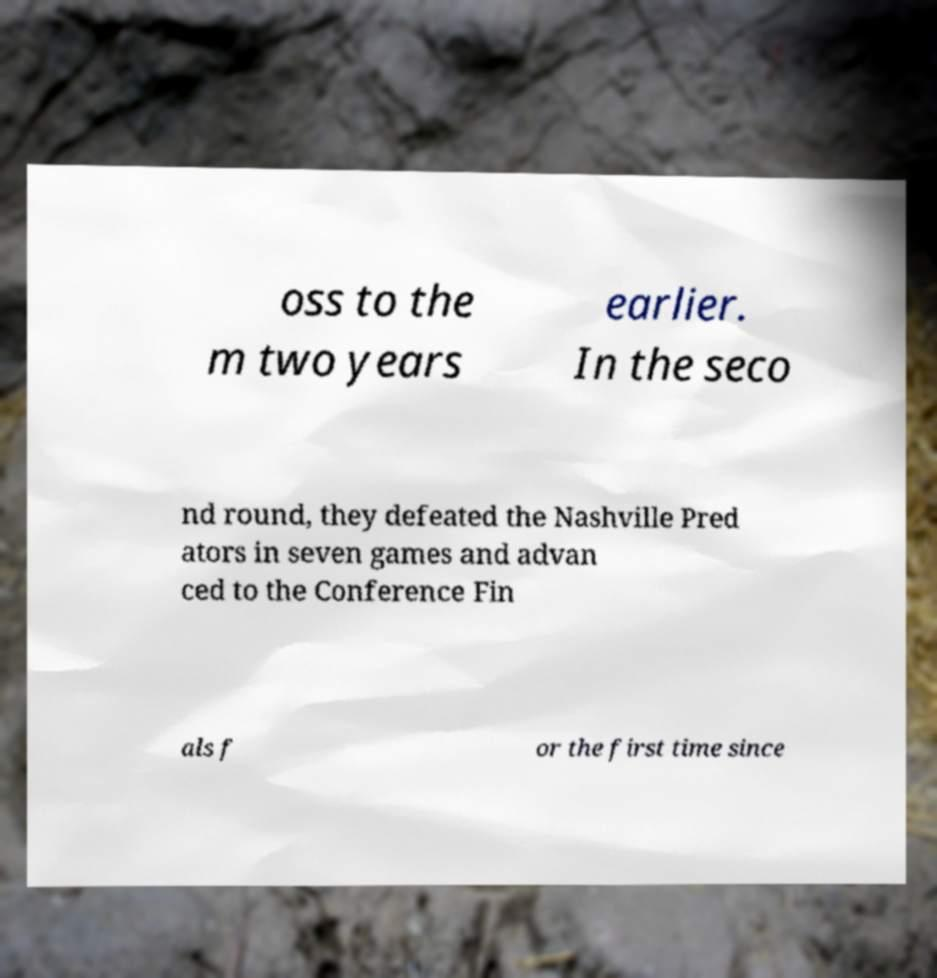There's text embedded in this image that I need extracted. Can you transcribe it verbatim? oss to the m two years earlier. In the seco nd round, they defeated the Nashville Pred ators in seven games and advan ced to the Conference Fin als f or the first time since 